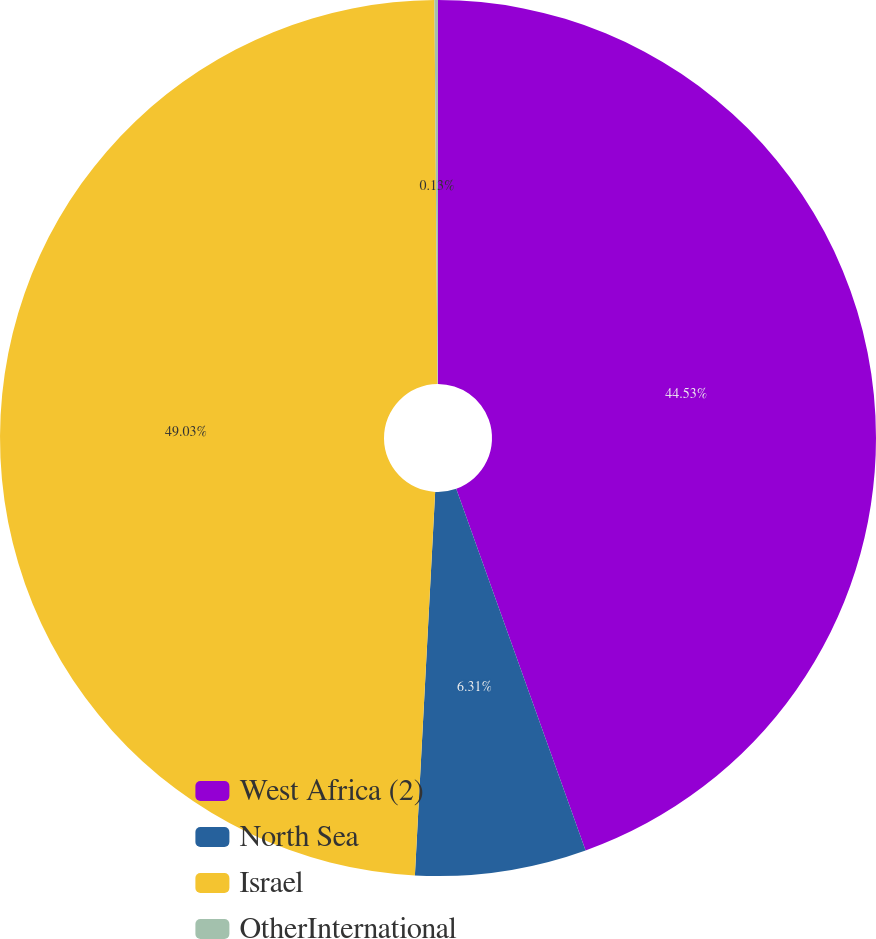Convert chart. <chart><loc_0><loc_0><loc_500><loc_500><pie_chart><fcel>West Africa (2)<fcel>North Sea<fcel>Israel<fcel>OtherInternational<nl><fcel>44.53%<fcel>6.31%<fcel>49.03%<fcel>0.13%<nl></chart> 